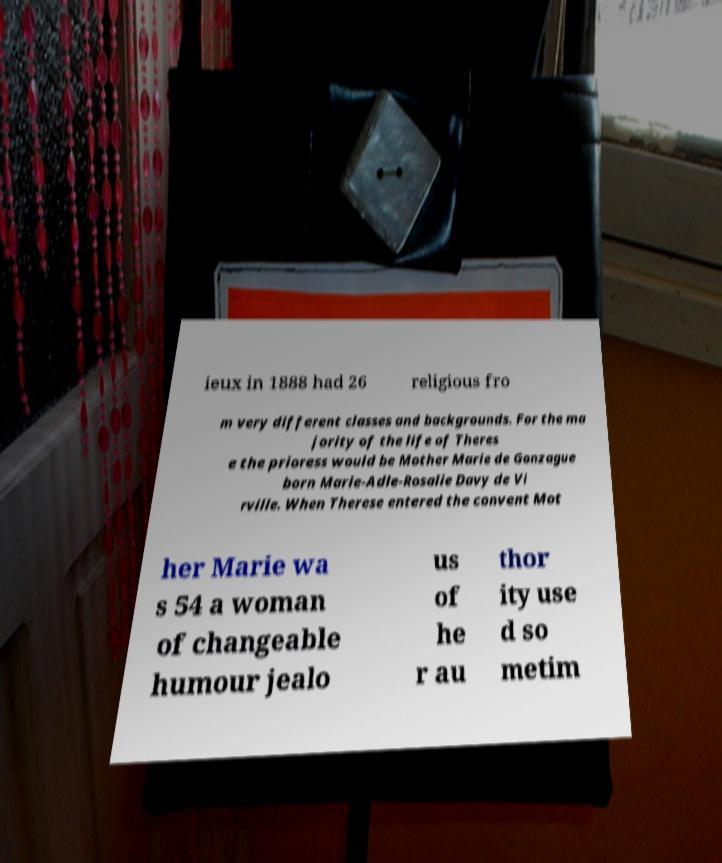For documentation purposes, I need the text within this image transcribed. Could you provide that? ieux in 1888 had 26 religious fro m very different classes and backgrounds. For the ma jority of the life of Theres e the prioress would be Mother Marie de Gonzague born Marie-Adle-Rosalie Davy de Vi rville. When Therese entered the convent Mot her Marie wa s 54 a woman of changeable humour jealo us of he r au thor ity use d so metim 